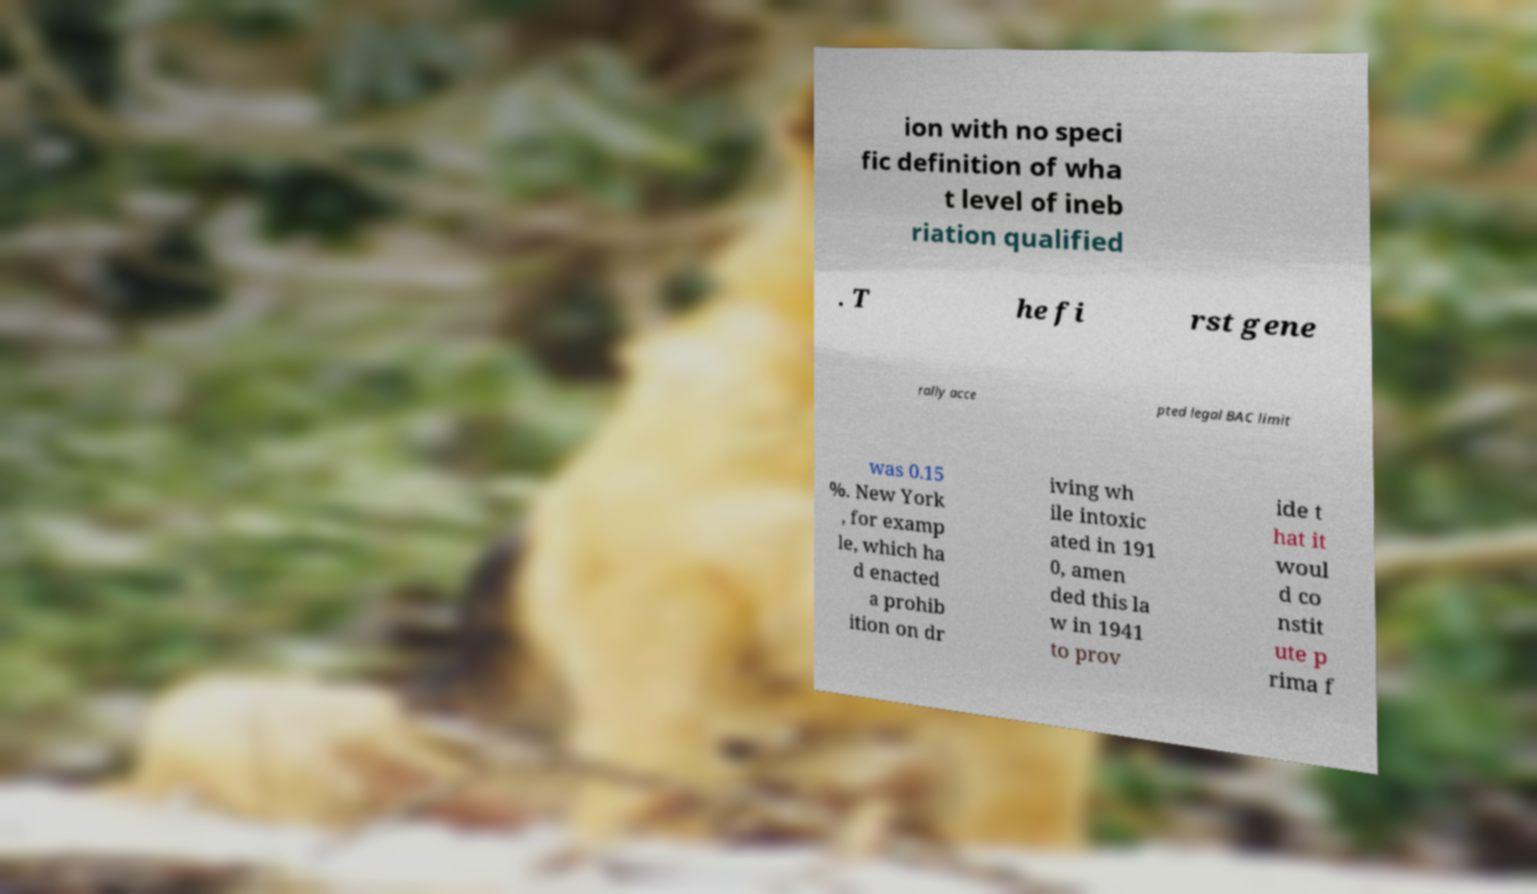Please identify and transcribe the text found in this image. ion with no speci fic definition of wha t level of ineb riation qualified . T he fi rst gene rally acce pted legal BAC limit was 0.15 %. New York , for examp le, which ha d enacted a prohib ition on dr iving wh ile intoxic ated in 191 0, amen ded this la w in 1941 to prov ide t hat it woul d co nstit ute p rima f 